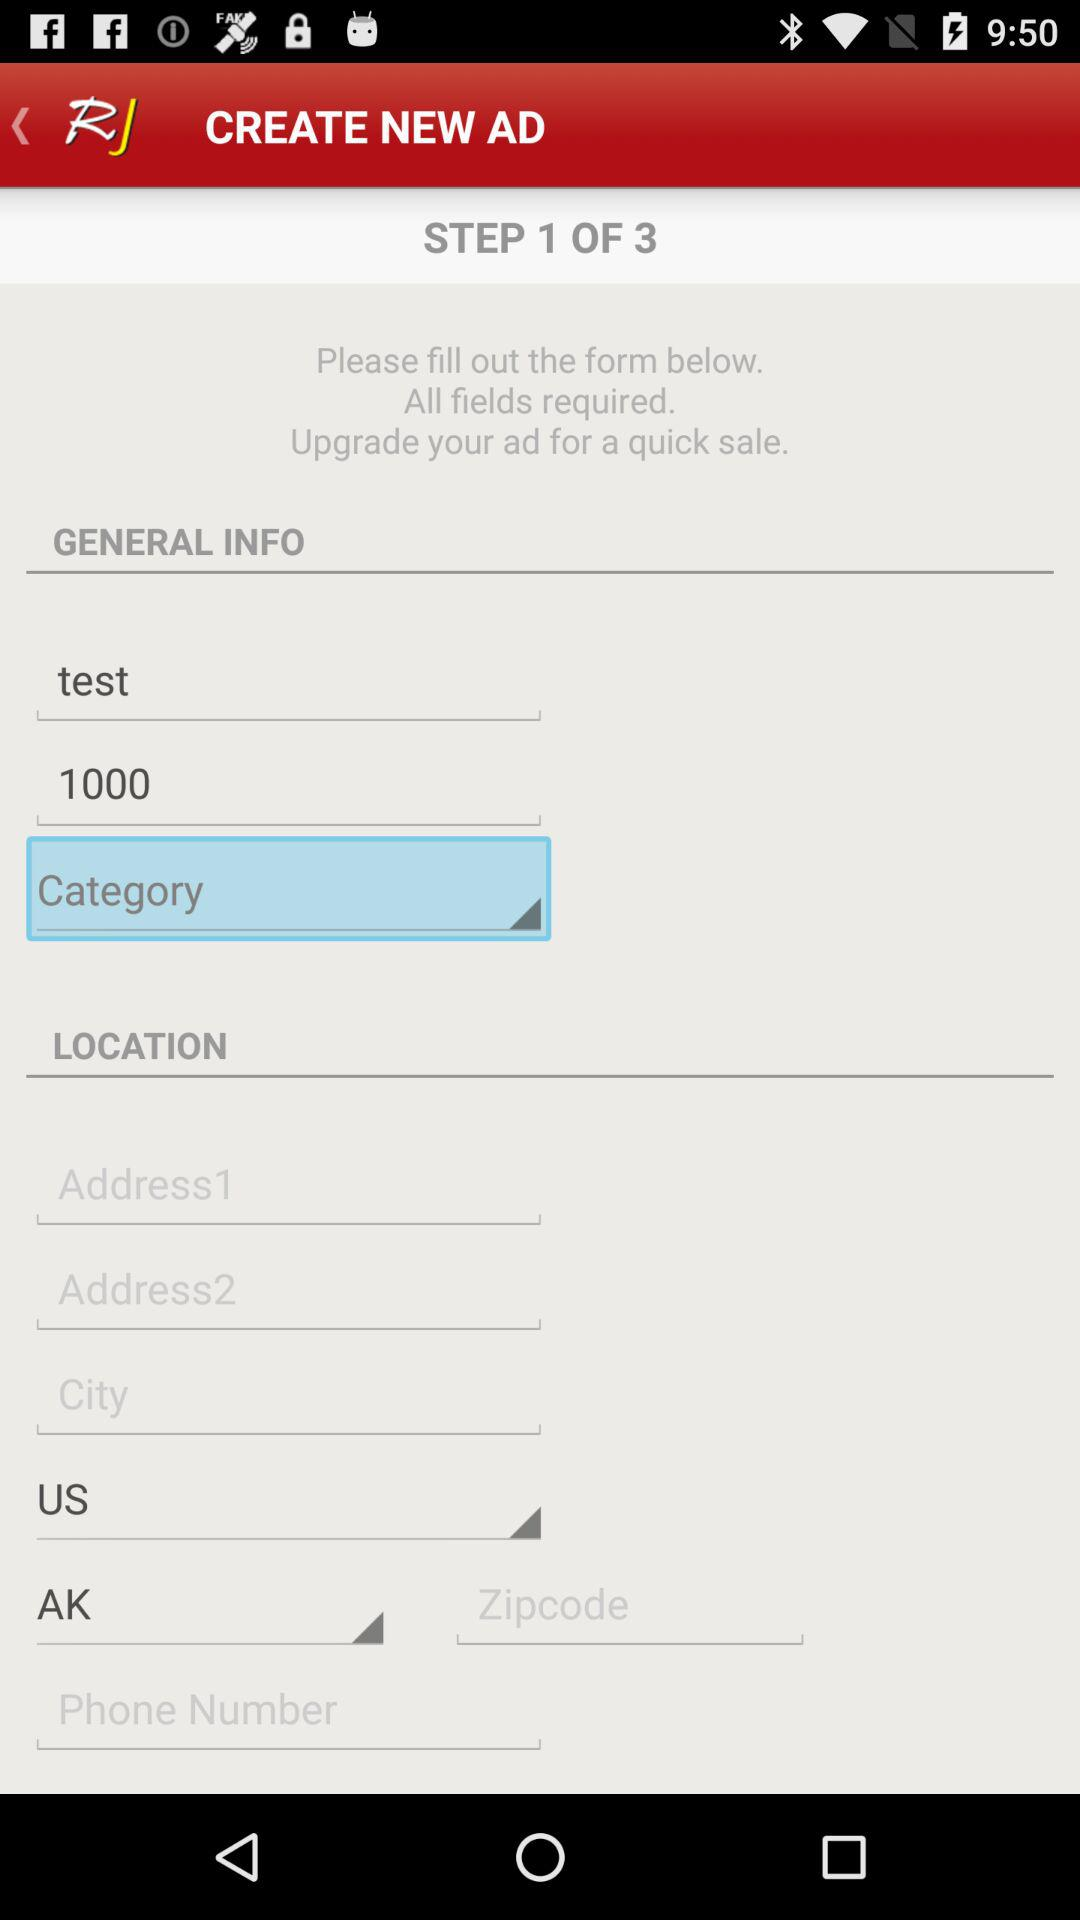At which step am I? You are at Step 1. 